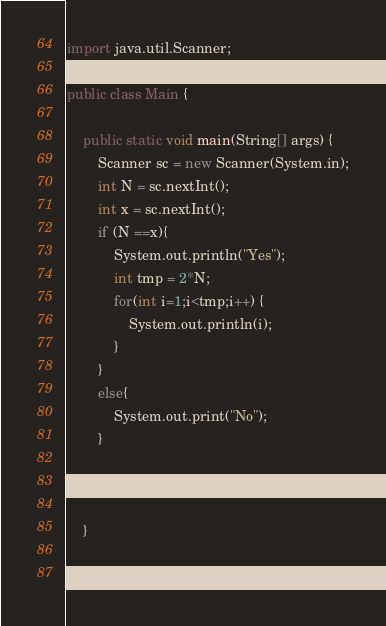Convert code to text. <code><loc_0><loc_0><loc_500><loc_500><_Java_>
import java.util.Scanner;

public class Main {

    public static void main(String[] args) {
        Scanner sc = new Scanner(System.in);
        int N = sc.nextInt();
        int x = sc.nextInt();
        if (N ==x){
            System.out.println("Yes");
            int tmp = 2*N;
            for(int i=1;i<tmp;i++) {
                System.out.println(i);
            }
        }
        else{
            System.out.print("No");
        }

        sc.close();

    }

 }
</code> 